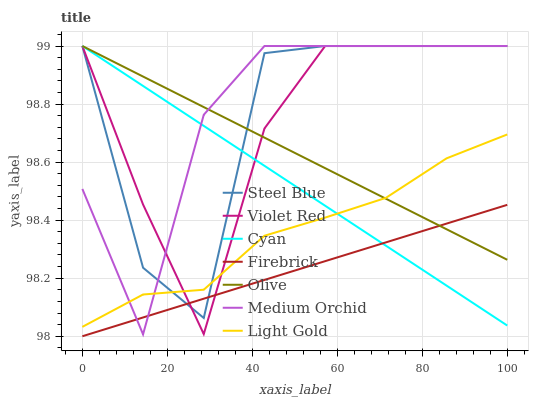Does Firebrick have the minimum area under the curve?
Answer yes or no. Yes. Does Medium Orchid have the maximum area under the curve?
Answer yes or no. Yes. Does Medium Orchid have the minimum area under the curve?
Answer yes or no. No. Does Firebrick have the maximum area under the curve?
Answer yes or no. No. Is Cyan the smoothest?
Answer yes or no. Yes. Is Steel Blue the roughest?
Answer yes or no. Yes. Is Firebrick the smoothest?
Answer yes or no. No. Is Firebrick the roughest?
Answer yes or no. No. Does Firebrick have the lowest value?
Answer yes or no. Yes. Does Medium Orchid have the lowest value?
Answer yes or no. No. Does Cyan have the highest value?
Answer yes or no. Yes. Does Firebrick have the highest value?
Answer yes or no. No. Is Firebrick less than Light Gold?
Answer yes or no. Yes. Is Light Gold greater than Firebrick?
Answer yes or no. Yes. Does Steel Blue intersect Cyan?
Answer yes or no. Yes. Is Steel Blue less than Cyan?
Answer yes or no. No. Is Steel Blue greater than Cyan?
Answer yes or no. No. Does Firebrick intersect Light Gold?
Answer yes or no. No. 